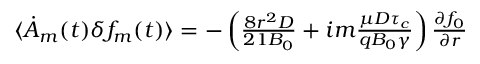<formula> <loc_0><loc_0><loc_500><loc_500>\begin{array} { r } { \langle \dot { A } _ { m } ( t ) \delta f _ { m } ( t ) \rangle = - \left ( \frac { 8 r ^ { 2 } D } { 2 1 B _ { 0 } } + i m \frac { \mu D \tau _ { c } } { q B _ { 0 } \gamma } \right ) \frac { \partial f _ { 0 } } { \partial r } } \end{array}</formula> 